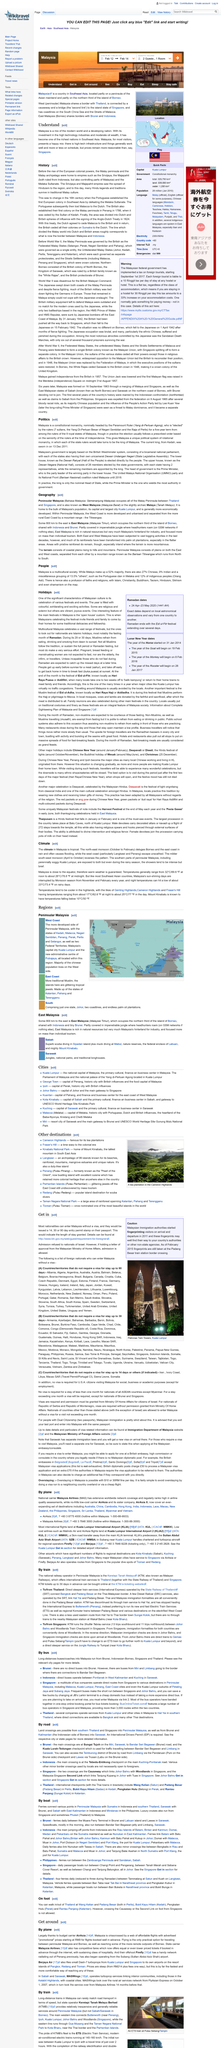Highlight a few significant elements in this photo. Malaysia is located in Southeast Asia, making it a country that is easily accessible to many travelers and tourists. The check-in date for the reservation is February 12, and the check-out date is February 14. Malaysia is divided into two parts, one located on the Asian mainland and bordering Thailand, and the other located on the island of Borneo and bordering Brunei and Indonesia. 